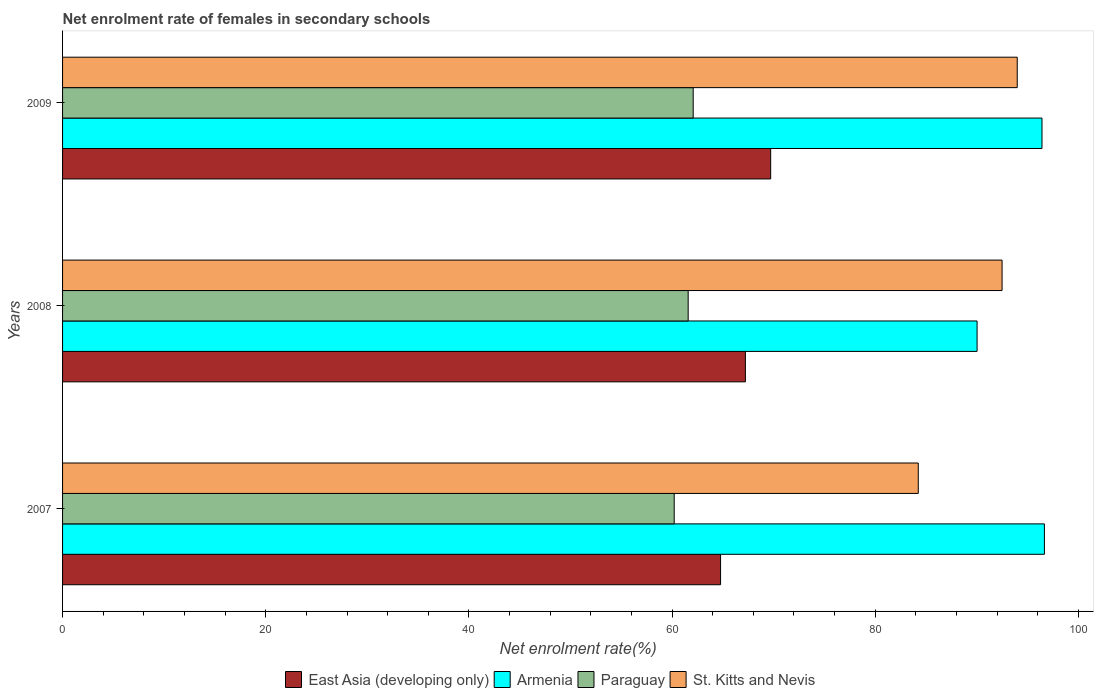How many different coloured bars are there?
Provide a succinct answer. 4. Are the number of bars on each tick of the Y-axis equal?
Give a very brief answer. Yes. How many bars are there on the 1st tick from the bottom?
Provide a short and direct response. 4. What is the label of the 3rd group of bars from the top?
Keep it short and to the point. 2007. In how many cases, is the number of bars for a given year not equal to the number of legend labels?
Your answer should be very brief. 0. What is the net enrolment rate of females in secondary schools in St. Kitts and Nevis in 2007?
Your answer should be very brief. 84.24. Across all years, what is the maximum net enrolment rate of females in secondary schools in Paraguay?
Keep it short and to the point. 62.08. Across all years, what is the minimum net enrolment rate of females in secondary schools in Paraguay?
Give a very brief answer. 60.21. What is the total net enrolment rate of females in secondary schools in Paraguay in the graph?
Provide a succinct answer. 183.88. What is the difference between the net enrolment rate of females in secondary schools in St. Kitts and Nevis in 2007 and that in 2008?
Provide a succinct answer. -8.25. What is the difference between the net enrolment rate of females in secondary schools in St. Kitts and Nevis in 2009 and the net enrolment rate of females in secondary schools in Paraguay in 2008?
Your response must be concise. 32.39. What is the average net enrolment rate of females in secondary schools in Paraguay per year?
Give a very brief answer. 61.29. In the year 2007, what is the difference between the net enrolment rate of females in secondary schools in Armenia and net enrolment rate of females in secondary schools in Paraguay?
Offer a terse response. 36.44. In how many years, is the net enrolment rate of females in secondary schools in Armenia greater than 52 %?
Your response must be concise. 3. What is the ratio of the net enrolment rate of females in secondary schools in Armenia in 2007 to that in 2009?
Your answer should be very brief. 1. Is the difference between the net enrolment rate of females in secondary schools in Armenia in 2008 and 2009 greater than the difference between the net enrolment rate of females in secondary schools in Paraguay in 2008 and 2009?
Your answer should be compact. No. What is the difference between the highest and the second highest net enrolment rate of females in secondary schools in East Asia (developing only)?
Offer a terse response. 2.49. What is the difference between the highest and the lowest net enrolment rate of females in secondary schools in Armenia?
Give a very brief answer. 6.63. In how many years, is the net enrolment rate of females in secondary schools in East Asia (developing only) greater than the average net enrolment rate of females in secondary schools in East Asia (developing only) taken over all years?
Provide a short and direct response. 1. Is it the case that in every year, the sum of the net enrolment rate of females in secondary schools in St. Kitts and Nevis and net enrolment rate of females in secondary schools in Armenia is greater than the sum of net enrolment rate of females in secondary schools in East Asia (developing only) and net enrolment rate of females in secondary schools in Paraguay?
Provide a succinct answer. Yes. What does the 1st bar from the top in 2008 represents?
Provide a succinct answer. St. Kitts and Nevis. What does the 1st bar from the bottom in 2008 represents?
Offer a terse response. East Asia (developing only). Is it the case that in every year, the sum of the net enrolment rate of females in secondary schools in St. Kitts and Nevis and net enrolment rate of females in secondary schools in Armenia is greater than the net enrolment rate of females in secondary schools in Paraguay?
Offer a very short reply. Yes. Are all the bars in the graph horizontal?
Provide a succinct answer. Yes. Where does the legend appear in the graph?
Keep it short and to the point. Bottom center. How many legend labels are there?
Ensure brevity in your answer.  4. How are the legend labels stacked?
Offer a very short reply. Horizontal. What is the title of the graph?
Provide a succinct answer. Net enrolment rate of females in secondary schools. What is the label or title of the X-axis?
Offer a terse response. Net enrolment rate(%). What is the Net enrolment rate(%) in East Asia (developing only) in 2007?
Give a very brief answer. 64.77. What is the Net enrolment rate(%) of Armenia in 2007?
Your answer should be very brief. 96.65. What is the Net enrolment rate(%) of Paraguay in 2007?
Provide a succinct answer. 60.21. What is the Net enrolment rate(%) in St. Kitts and Nevis in 2007?
Give a very brief answer. 84.24. What is the Net enrolment rate(%) of East Asia (developing only) in 2008?
Your answer should be very brief. 67.22. What is the Net enrolment rate(%) of Armenia in 2008?
Your answer should be very brief. 90.03. What is the Net enrolment rate(%) of Paraguay in 2008?
Make the answer very short. 61.59. What is the Net enrolment rate(%) in St. Kitts and Nevis in 2008?
Make the answer very short. 92.49. What is the Net enrolment rate(%) of East Asia (developing only) in 2009?
Make the answer very short. 69.71. What is the Net enrolment rate(%) in Armenia in 2009?
Your answer should be compact. 96.42. What is the Net enrolment rate(%) in Paraguay in 2009?
Offer a very short reply. 62.08. What is the Net enrolment rate(%) in St. Kitts and Nevis in 2009?
Your answer should be compact. 93.98. Across all years, what is the maximum Net enrolment rate(%) in East Asia (developing only)?
Make the answer very short. 69.71. Across all years, what is the maximum Net enrolment rate(%) of Armenia?
Provide a short and direct response. 96.65. Across all years, what is the maximum Net enrolment rate(%) in Paraguay?
Keep it short and to the point. 62.08. Across all years, what is the maximum Net enrolment rate(%) in St. Kitts and Nevis?
Ensure brevity in your answer.  93.98. Across all years, what is the minimum Net enrolment rate(%) of East Asia (developing only)?
Provide a succinct answer. 64.77. Across all years, what is the minimum Net enrolment rate(%) of Armenia?
Offer a very short reply. 90.03. Across all years, what is the minimum Net enrolment rate(%) in Paraguay?
Provide a succinct answer. 60.21. Across all years, what is the minimum Net enrolment rate(%) of St. Kitts and Nevis?
Your response must be concise. 84.24. What is the total Net enrolment rate(%) in East Asia (developing only) in the graph?
Ensure brevity in your answer.  201.7. What is the total Net enrolment rate(%) in Armenia in the graph?
Provide a short and direct response. 283.1. What is the total Net enrolment rate(%) of Paraguay in the graph?
Your response must be concise. 183.88. What is the total Net enrolment rate(%) of St. Kitts and Nevis in the graph?
Offer a very short reply. 270.71. What is the difference between the Net enrolment rate(%) of East Asia (developing only) in 2007 and that in 2008?
Make the answer very short. -2.44. What is the difference between the Net enrolment rate(%) of Armenia in 2007 and that in 2008?
Your answer should be very brief. 6.63. What is the difference between the Net enrolment rate(%) of Paraguay in 2007 and that in 2008?
Ensure brevity in your answer.  -1.38. What is the difference between the Net enrolment rate(%) in St. Kitts and Nevis in 2007 and that in 2008?
Your answer should be compact. -8.25. What is the difference between the Net enrolment rate(%) of East Asia (developing only) in 2007 and that in 2009?
Your answer should be compact. -4.93. What is the difference between the Net enrolment rate(%) of Armenia in 2007 and that in 2009?
Offer a terse response. 0.24. What is the difference between the Net enrolment rate(%) in Paraguay in 2007 and that in 2009?
Ensure brevity in your answer.  -1.87. What is the difference between the Net enrolment rate(%) of St. Kitts and Nevis in 2007 and that in 2009?
Your answer should be compact. -9.74. What is the difference between the Net enrolment rate(%) in East Asia (developing only) in 2008 and that in 2009?
Your response must be concise. -2.49. What is the difference between the Net enrolment rate(%) of Armenia in 2008 and that in 2009?
Your answer should be very brief. -6.39. What is the difference between the Net enrolment rate(%) in Paraguay in 2008 and that in 2009?
Your response must be concise. -0.49. What is the difference between the Net enrolment rate(%) of St. Kitts and Nevis in 2008 and that in 2009?
Your response must be concise. -1.49. What is the difference between the Net enrolment rate(%) of East Asia (developing only) in 2007 and the Net enrolment rate(%) of Armenia in 2008?
Your response must be concise. -25.25. What is the difference between the Net enrolment rate(%) in East Asia (developing only) in 2007 and the Net enrolment rate(%) in Paraguay in 2008?
Keep it short and to the point. 3.19. What is the difference between the Net enrolment rate(%) in East Asia (developing only) in 2007 and the Net enrolment rate(%) in St. Kitts and Nevis in 2008?
Offer a very short reply. -27.71. What is the difference between the Net enrolment rate(%) of Armenia in 2007 and the Net enrolment rate(%) of Paraguay in 2008?
Provide a short and direct response. 35.07. What is the difference between the Net enrolment rate(%) of Armenia in 2007 and the Net enrolment rate(%) of St. Kitts and Nevis in 2008?
Provide a succinct answer. 4.17. What is the difference between the Net enrolment rate(%) of Paraguay in 2007 and the Net enrolment rate(%) of St. Kitts and Nevis in 2008?
Provide a succinct answer. -32.28. What is the difference between the Net enrolment rate(%) in East Asia (developing only) in 2007 and the Net enrolment rate(%) in Armenia in 2009?
Provide a short and direct response. -31.64. What is the difference between the Net enrolment rate(%) of East Asia (developing only) in 2007 and the Net enrolment rate(%) of Paraguay in 2009?
Your response must be concise. 2.69. What is the difference between the Net enrolment rate(%) in East Asia (developing only) in 2007 and the Net enrolment rate(%) in St. Kitts and Nevis in 2009?
Provide a short and direct response. -29.21. What is the difference between the Net enrolment rate(%) of Armenia in 2007 and the Net enrolment rate(%) of Paraguay in 2009?
Provide a succinct answer. 34.57. What is the difference between the Net enrolment rate(%) of Armenia in 2007 and the Net enrolment rate(%) of St. Kitts and Nevis in 2009?
Your answer should be very brief. 2.67. What is the difference between the Net enrolment rate(%) of Paraguay in 2007 and the Net enrolment rate(%) of St. Kitts and Nevis in 2009?
Your answer should be compact. -33.77. What is the difference between the Net enrolment rate(%) of East Asia (developing only) in 2008 and the Net enrolment rate(%) of Armenia in 2009?
Offer a terse response. -29.2. What is the difference between the Net enrolment rate(%) in East Asia (developing only) in 2008 and the Net enrolment rate(%) in Paraguay in 2009?
Offer a terse response. 5.14. What is the difference between the Net enrolment rate(%) of East Asia (developing only) in 2008 and the Net enrolment rate(%) of St. Kitts and Nevis in 2009?
Provide a short and direct response. -26.76. What is the difference between the Net enrolment rate(%) of Armenia in 2008 and the Net enrolment rate(%) of Paraguay in 2009?
Make the answer very short. 27.95. What is the difference between the Net enrolment rate(%) of Armenia in 2008 and the Net enrolment rate(%) of St. Kitts and Nevis in 2009?
Keep it short and to the point. -3.95. What is the difference between the Net enrolment rate(%) in Paraguay in 2008 and the Net enrolment rate(%) in St. Kitts and Nevis in 2009?
Your answer should be compact. -32.39. What is the average Net enrolment rate(%) of East Asia (developing only) per year?
Provide a succinct answer. 67.23. What is the average Net enrolment rate(%) in Armenia per year?
Your answer should be compact. 94.37. What is the average Net enrolment rate(%) in Paraguay per year?
Your response must be concise. 61.29. What is the average Net enrolment rate(%) of St. Kitts and Nevis per year?
Provide a short and direct response. 90.24. In the year 2007, what is the difference between the Net enrolment rate(%) in East Asia (developing only) and Net enrolment rate(%) in Armenia?
Provide a succinct answer. -31.88. In the year 2007, what is the difference between the Net enrolment rate(%) of East Asia (developing only) and Net enrolment rate(%) of Paraguay?
Offer a very short reply. 4.56. In the year 2007, what is the difference between the Net enrolment rate(%) of East Asia (developing only) and Net enrolment rate(%) of St. Kitts and Nevis?
Provide a succinct answer. -19.46. In the year 2007, what is the difference between the Net enrolment rate(%) of Armenia and Net enrolment rate(%) of Paraguay?
Make the answer very short. 36.44. In the year 2007, what is the difference between the Net enrolment rate(%) of Armenia and Net enrolment rate(%) of St. Kitts and Nevis?
Keep it short and to the point. 12.42. In the year 2007, what is the difference between the Net enrolment rate(%) in Paraguay and Net enrolment rate(%) in St. Kitts and Nevis?
Provide a succinct answer. -24.03. In the year 2008, what is the difference between the Net enrolment rate(%) of East Asia (developing only) and Net enrolment rate(%) of Armenia?
Offer a terse response. -22.81. In the year 2008, what is the difference between the Net enrolment rate(%) in East Asia (developing only) and Net enrolment rate(%) in Paraguay?
Your answer should be compact. 5.63. In the year 2008, what is the difference between the Net enrolment rate(%) in East Asia (developing only) and Net enrolment rate(%) in St. Kitts and Nevis?
Your answer should be compact. -25.27. In the year 2008, what is the difference between the Net enrolment rate(%) in Armenia and Net enrolment rate(%) in Paraguay?
Make the answer very short. 28.44. In the year 2008, what is the difference between the Net enrolment rate(%) of Armenia and Net enrolment rate(%) of St. Kitts and Nevis?
Provide a succinct answer. -2.46. In the year 2008, what is the difference between the Net enrolment rate(%) in Paraguay and Net enrolment rate(%) in St. Kitts and Nevis?
Your answer should be very brief. -30.9. In the year 2009, what is the difference between the Net enrolment rate(%) of East Asia (developing only) and Net enrolment rate(%) of Armenia?
Your response must be concise. -26.71. In the year 2009, what is the difference between the Net enrolment rate(%) in East Asia (developing only) and Net enrolment rate(%) in Paraguay?
Make the answer very short. 7.63. In the year 2009, what is the difference between the Net enrolment rate(%) in East Asia (developing only) and Net enrolment rate(%) in St. Kitts and Nevis?
Offer a very short reply. -24.27. In the year 2009, what is the difference between the Net enrolment rate(%) of Armenia and Net enrolment rate(%) of Paraguay?
Provide a short and direct response. 34.34. In the year 2009, what is the difference between the Net enrolment rate(%) in Armenia and Net enrolment rate(%) in St. Kitts and Nevis?
Your answer should be compact. 2.44. In the year 2009, what is the difference between the Net enrolment rate(%) in Paraguay and Net enrolment rate(%) in St. Kitts and Nevis?
Offer a very short reply. -31.9. What is the ratio of the Net enrolment rate(%) of East Asia (developing only) in 2007 to that in 2008?
Your answer should be very brief. 0.96. What is the ratio of the Net enrolment rate(%) in Armenia in 2007 to that in 2008?
Make the answer very short. 1.07. What is the ratio of the Net enrolment rate(%) in Paraguay in 2007 to that in 2008?
Your response must be concise. 0.98. What is the ratio of the Net enrolment rate(%) in St. Kitts and Nevis in 2007 to that in 2008?
Your answer should be very brief. 0.91. What is the ratio of the Net enrolment rate(%) in East Asia (developing only) in 2007 to that in 2009?
Keep it short and to the point. 0.93. What is the ratio of the Net enrolment rate(%) in Armenia in 2007 to that in 2009?
Keep it short and to the point. 1. What is the ratio of the Net enrolment rate(%) in Paraguay in 2007 to that in 2009?
Provide a succinct answer. 0.97. What is the ratio of the Net enrolment rate(%) in St. Kitts and Nevis in 2007 to that in 2009?
Your response must be concise. 0.9. What is the ratio of the Net enrolment rate(%) of Armenia in 2008 to that in 2009?
Your response must be concise. 0.93. What is the ratio of the Net enrolment rate(%) of St. Kitts and Nevis in 2008 to that in 2009?
Your response must be concise. 0.98. What is the difference between the highest and the second highest Net enrolment rate(%) in East Asia (developing only)?
Your response must be concise. 2.49. What is the difference between the highest and the second highest Net enrolment rate(%) of Armenia?
Give a very brief answer. 0.24. What is the difference between the highest and the second highest Net enrolment rate(%) of Paraguay?
Keep it short and to the point. 0.49. What is the difference between the highest and the second highest Net enrolment rate(%) of St. Kitts and Nevis?
Provide a succinct answer. 1.49. What is the difference between the highest and the lowest Net enrolment rate(%) in East Asia (developing only)?
Offer a terse response. 4.93. What is the difference between the highest and the lowest Net enrolment rate(%) of Armenia?
Give a very brief answer. 6.63. What is the difference between the highest and the lowest Net enrolment rate(%) in Paraguay?
Keep it short and to the point. 1.87. What is the difference between the highest and the lowest Net enrolment rate(%) in St. Kitts and Nevis?
Your answer should be very brief. 9.74. 